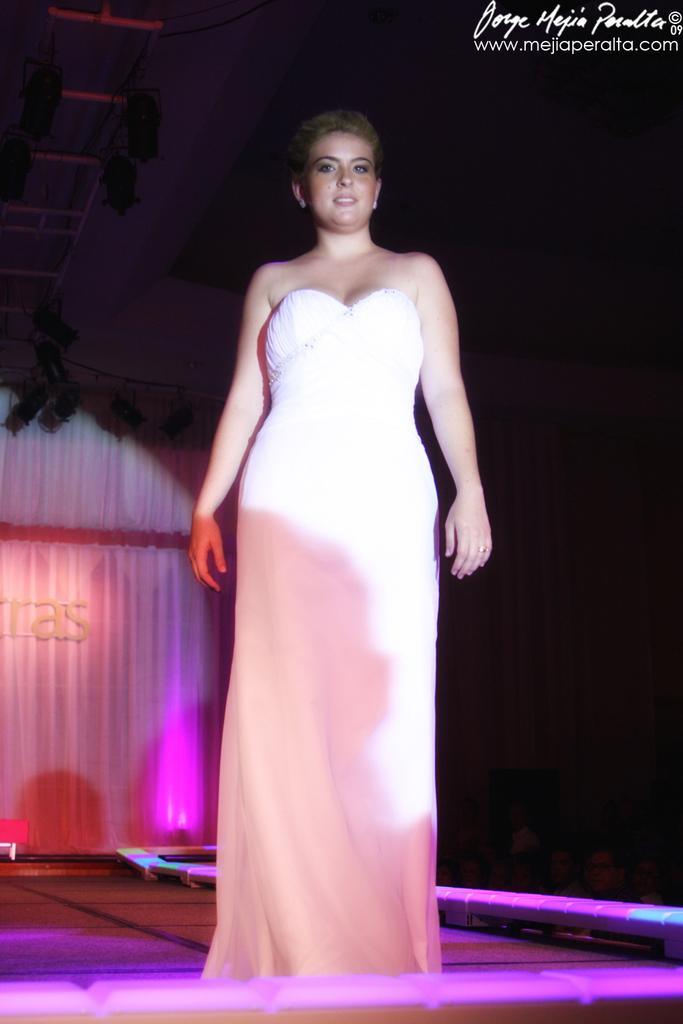Can you describe this image briefly? In the picture we can see a woman standing on the stage, she is with a white dress and behind her we can see a curtain which is white in color with a pink color light focus on it. 